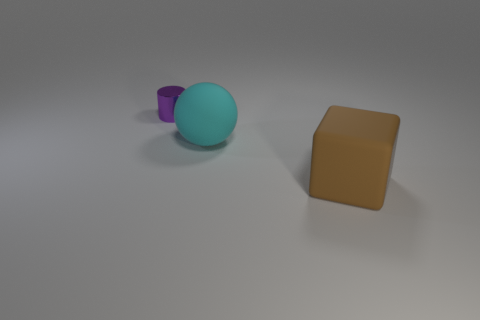Add 3 big cyan matte spheres. How many objects exist? 6 Subtract 0 cyan cylinders. How many objects are left? 3 Subtract all cylinders. How many objects are left? 2 Subtract all gray balls. Subtract all purple blocks. How many balls are left? 1 Subtract all tiny shiny objects. Subtract all cylinders. How many objects are left? 1 Add 1 large brown objects. How many large brown objects are left? 2 Add 3 small purple objects. How many small purple objects exist? 4 